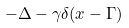<formula> <loc_0><loc_0><loc_500><loc_500>- \Delta - \gamma \delta ( x - \Gamma )</formula> 